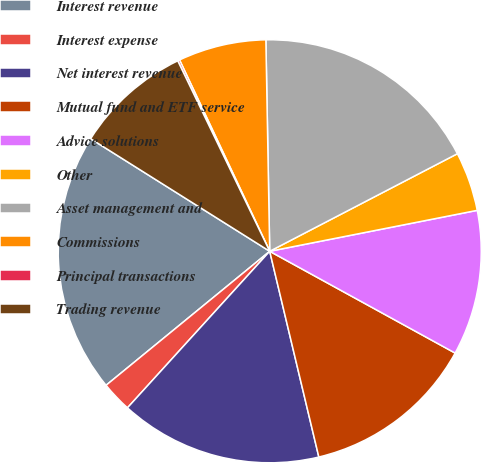Convert chart. <chart><loc_0><loc_0><loc_500><loc_500><pie_chart><fcel>Interest revenue<fcel>Interest expense<fcel>Net interest revenue<fcel>Mutual fund and ETF service<fcel>Advice solutions<fcel>Other<fcel>Asset management and<fcel>Commissions<fcel>Principal transactions<fcel>Trading revenue<nl><fcel>19.85%<fcel>2.34%<fcel>15.47%<fcel>13.28%<fcel>11.09%<fcel>4.53%<fcel>17.66%<fcel>6.72%<fcel>0.15%<fcel>8.91%<nl></chart> 